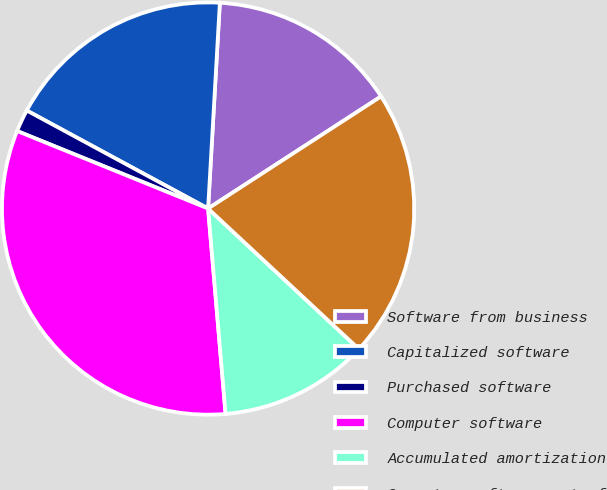Convert chart. <chart><loc_0><loc_0><loc_500><loc_500><pie_chart><fcel>Software from business<fcel>Capitalized software<fcel>Purchased software<fcel>Computer software<fcel>Accumulated amortization<fcel>Computer software net of<nl><fcel>14.94%<fcel>18.02%<fcel>1.75%<fcel>32.49%<fcel>11.71%<fcel>21.09%<nl></chart> 